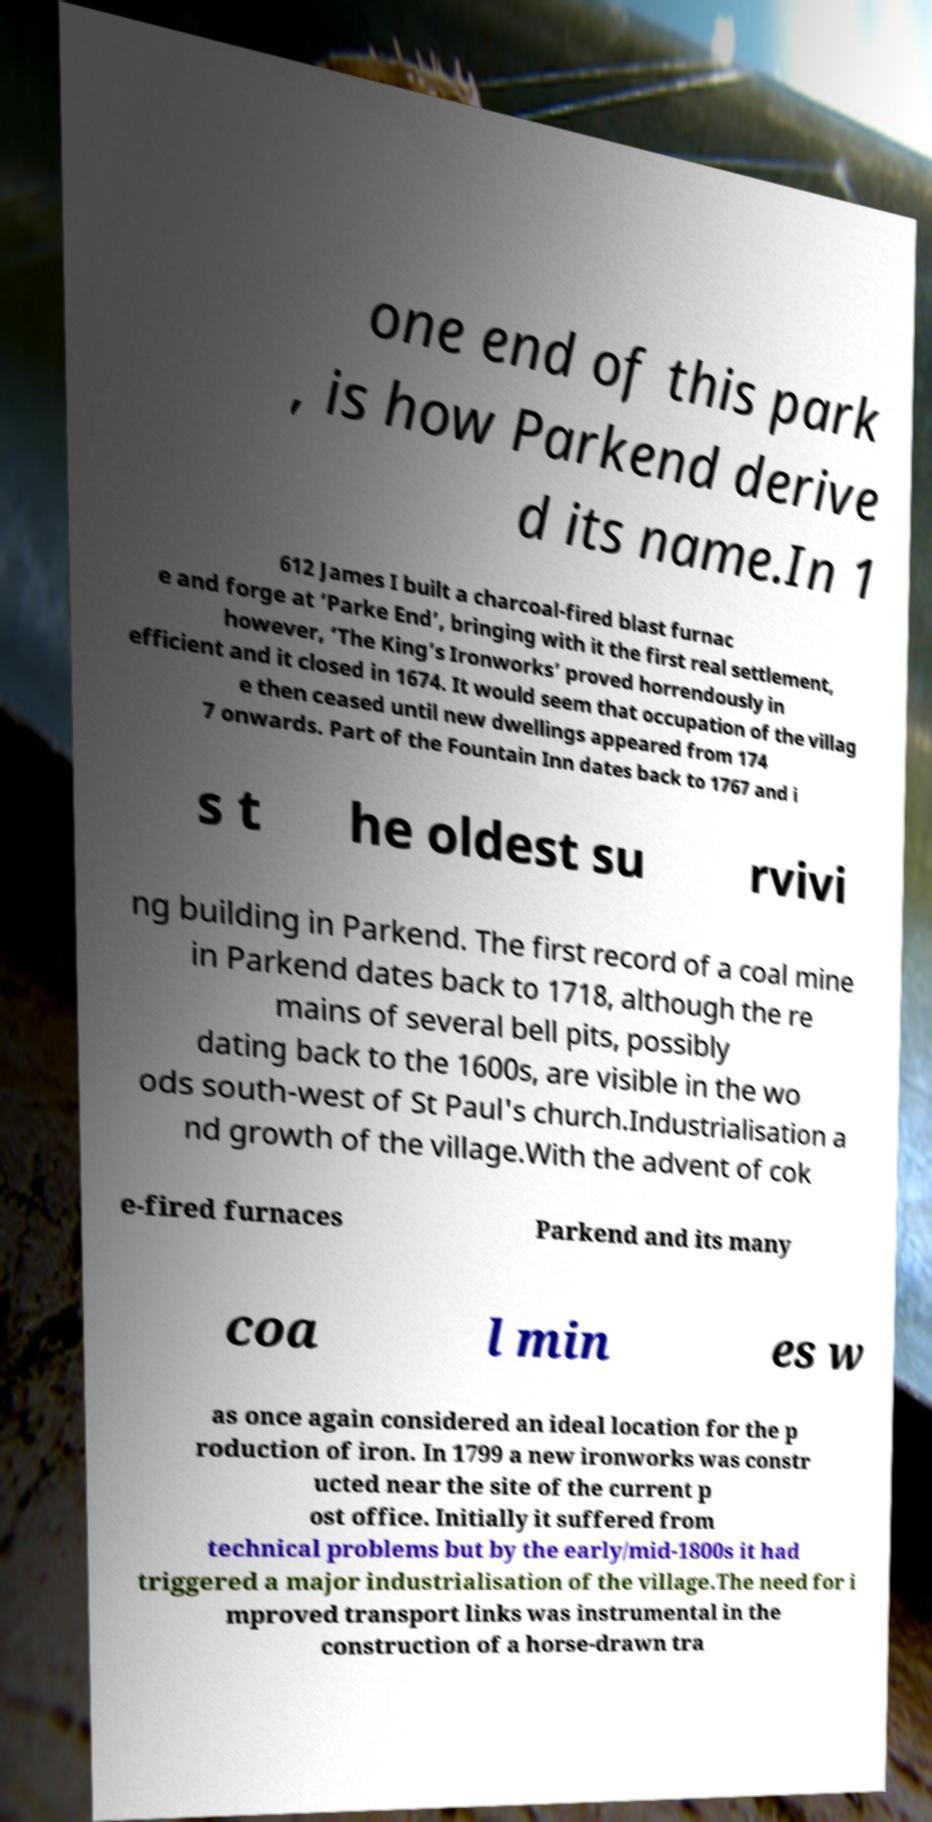Could you extract and type out the text from this image? one end of this park , is how Parkend derive d its name.In 1 612 James I built a charcoal-fired blast furnac e and forge at ‘Parke End’, bringing with it the first real settlement, however, ‘The King’s Ironworks’ proved horrendously in efficient and it closed in 1674. It would seem that occupation of the villag e then ceased until new dwellings appeared from 174 7 onwards. Part of the Fountain Inn dates back to 1767 and i s t he oldest su rvivi ng building in Parkend. The first record of a coal mine in Parkend dates back to 1718, although the re mains of several bell pits, possibly dating back to the 1600s, are visible in the wo ods south-west of St Paul's church.Industrialisation a nd growth of the village.With the advent of cok e-fired furnaces Parkend and its many coa l min es w as once again considered an ideal location for the p roduction of iron. In 1799 a new ironworks was constr ucted near the site of the current p ost office. Initially it suffered from technical problems but by the early/mid-1800s it had triggered a major industrialisation of the village.The need for i mproved transport links was instrumental in the construction of a horse-drawn tra 